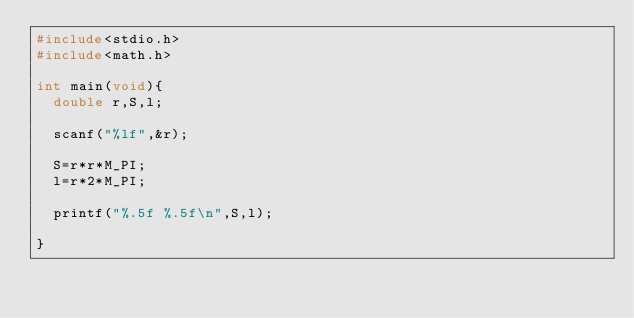<code> <loc_0><loc_0><loc_500><loc_500><_C_>#include<stdio.h>
#include<math.h>

int main(void){
  double r,S,l;

  scanf("%lf",&r);

  S=r*r*M_PI;
  l=r*2*M_PI;

  printf("%.5f %.5f\n",S,l);

}
  

</code> 